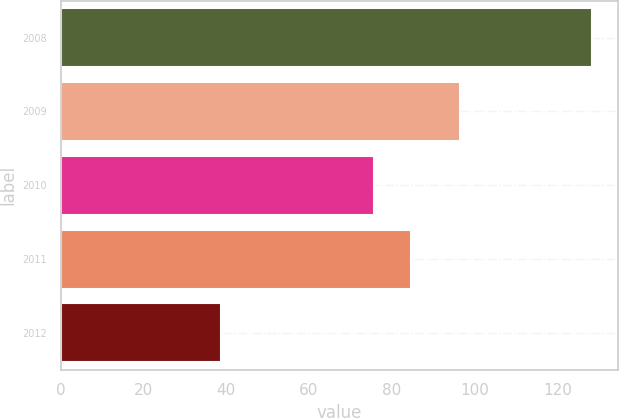Convert chart. <chart><loc_0><loc_0><loc_500><loc_500><bar_chart><fcel>2008<fcel>2009<fcel>2010<fcel>2011<fcel>2012<nl><fcel>128.3<fcel>96.4<fcel>75.8<fcel>84.76<fcel>38.7<nl></chart> 